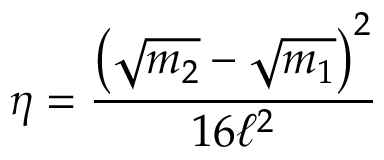<formula> <loc_0><loc_0><loc_500><loc_500>\eta = \frac { { \left ( \sqrt { m _ { 2 } } - \sqrt { m _ { 1 } } \right ) } ^ { 2 } } { 1 6 \ell ^ { 2 } }</formula> 